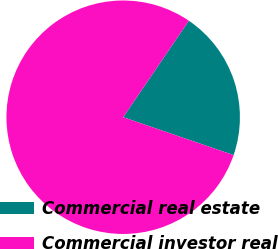Convert chart to OTSL. <chart><loc_0><loc_0><loc_500><loc_500><pie_chart><fcel>Commercial real estate<fcel>Commercial investor real<nl><fcel>20.75%<fcel>79.25%<nl></chart> 